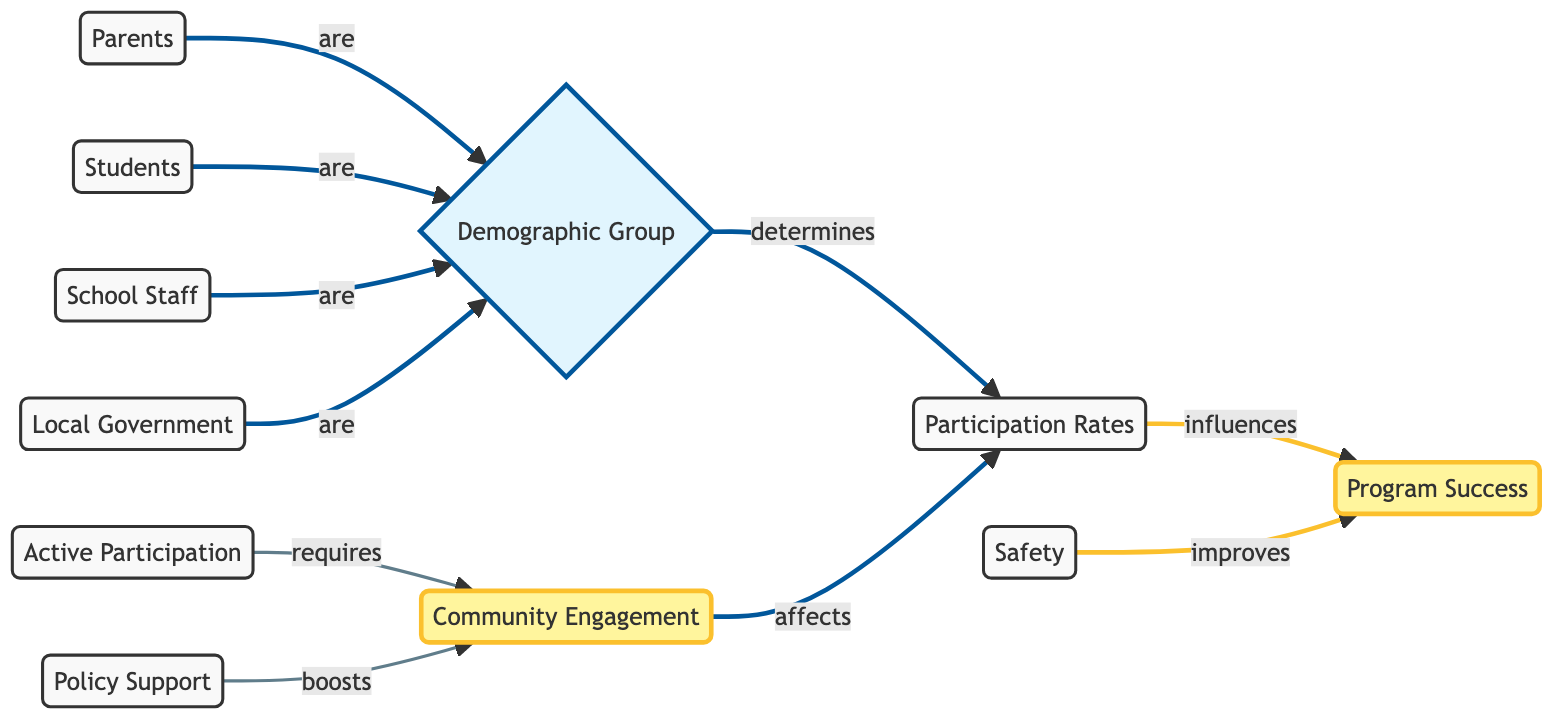What is the main focus of the diagram? The diagram highlights "Community Engagement" as the central point, indicating that it is the primary theme explored within the context of safe routes to school.
Answer: Community Engagement How many demographic groups are represented in the diagram? The diagram features four demographic groups: Parents, Students, School Staff, and Local Government, indicated by the nodes branching from the "Demographic Group" node.
Answer: Four Which node directly influences Program Success? "Participation Rates" is shown to influence "Program Success," as indicated by the direct arrow connecting the two nodes in the flowchart.
Answer: Participation Rates What do "Safety" and "Active Participation" contribute to in the diagram? Both "Safety" and "Active Participation" are identified as factors that improve "Program Success," as they are connected directly to this node in the diagram.
Answer: Program Success Which node requires Community Engagement? "Active Participation" is indicated as requiring "Community Engagement," meaning that for active participation to occur, community engagement is necessary.
Answer: Community Engagement How do "Policy Support" and "Safety" relate to Community Engagement? Both "Policy Support" and "Safety" are shown to have a direct link to improving "Community Engagement," illustrating their importance in this context.
Answer: Improve Community Engagement Which demographic group correlates with Local Government? The demographic group of "Local Government" is represented in the same way as Parents, Students, and School Staff, indicating that all four are essential participants in community engagement efforts for safe routes to school.
Answer: All groups What is the link between "Community Engagement" and "Participation Rates"? "Community Engagement" is shown to affect "Participation Rates," suggesting that higher engagement leads to increased participation in the program.
Answer: Affects Which aspect enhances Program Success the most according to the diagram? The diagram indicates that factors like "Safety" improve "Program Success," highlighting its significant role in ensuring the effectiveness of the program.
Answer: Safety 